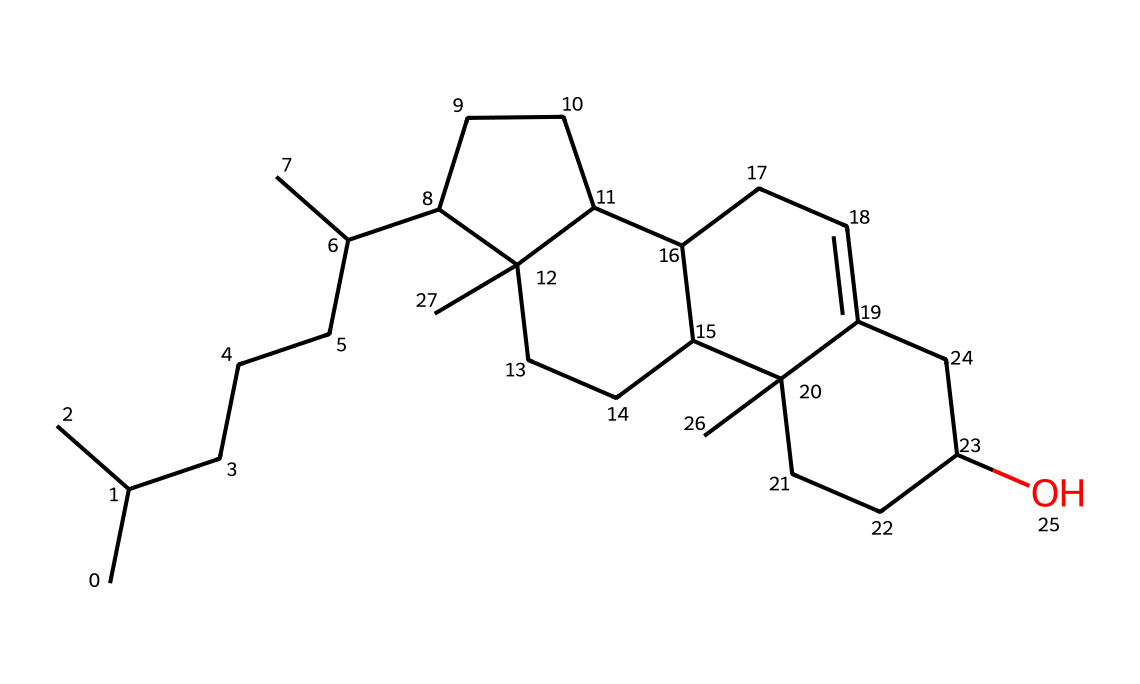What is the molecular formula for cholesterol? To determine the molecular formula from the SMILES representation, we can count the carbon (C), hydrogen (H), and oxygen (O) atoms. The presence of the various components tells us that the molecule consists of 27 carbons, 46 hydrogens, and 1 oxygen. Thus, the molecular formula is C27H46O.
Answer: C27H46O How many rings are present in the cholesterol structure? The structure can be analyzed to find the number of cyclic components based on the connections in the SMILES string. Cholesterol contains four interconnected rings. Therefore, the total count of rings in cholesterol is four.
Answer: four What type of lipid is cholesterol classified as? Cholesterol is classified as a sterol, a type of lipid characterized by a specific chemical structure including a hydroxyl group and a steroid core. This classification can be directly associated with cholesterol as it possesses these features.
Answer: sterol What is the significance of the hydroxyl group in cholesterol? The hydroxyl group in cholesterol contributes to its amphipathic nature—partly hydrophilic (water-attracting) and partly hydrophobic (water-repelling). This property is crucial for its role in the membrane structure and function, helping to stabilize cell membranes.
Answer: amphipathic How many total hydrogen atoms are present in the cholesterol structure? Hydrogen atoms can be counted from the molecular formula once identified: if we look at C27H46O, it tells us directly that there are 46 hydrogen atoms in cholesterol.
Answer: 46 